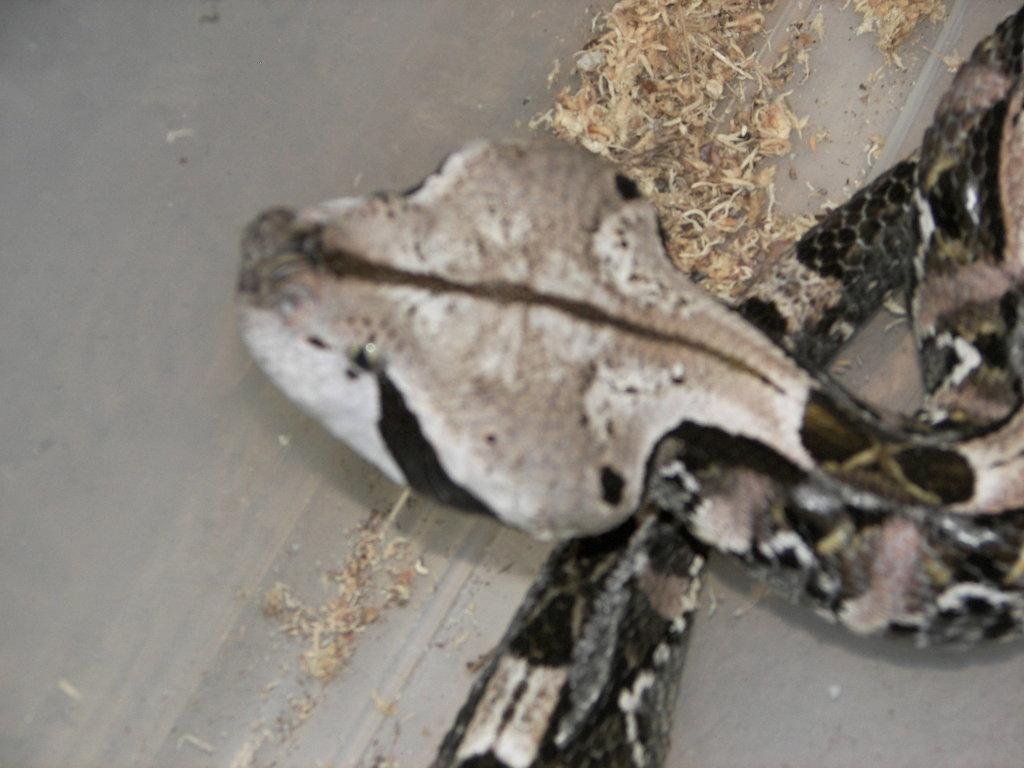What type of animal is present in the image? There is a snake in the image. What type of quill is the snake using to write a letter in the image? There is no quill or letter-writing activity present in the image; it features a snake. 